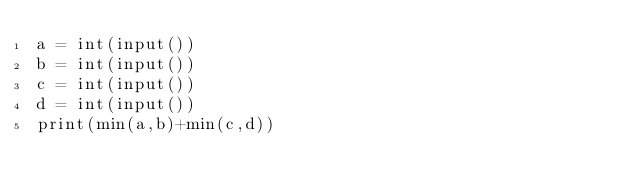<code> <loc_0><loc_0><loc_500><loc_500><_Python_>a = int(input())
b = int(input())
c = int(input())
d = int(input())
print(min(a,b)+min(c,d))</code> 